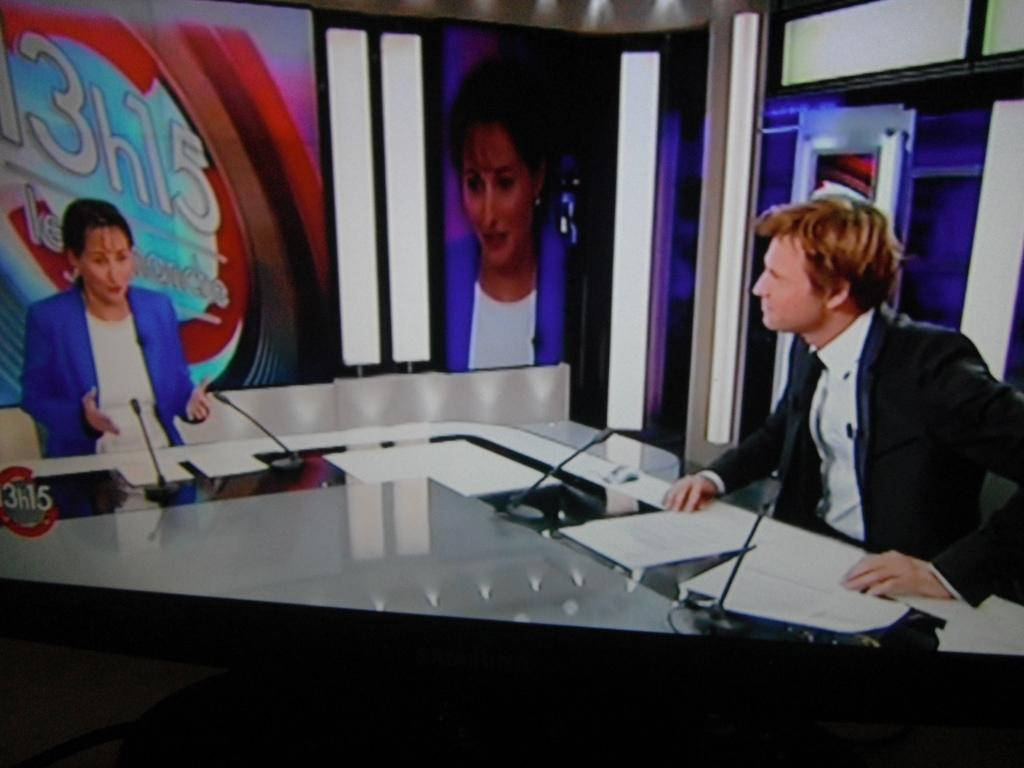Who can be seen sitting in the image? There is a woman and a man sitting in the image. What is present in the image besides the people? There is a table in the image. What items are on the table? There are miles and papers on the table. What type of decorations are visible in the image? There are posters in the image. What type of note can be seen on the quartz surface in the image? There is no quartz surface or note present in the image. 